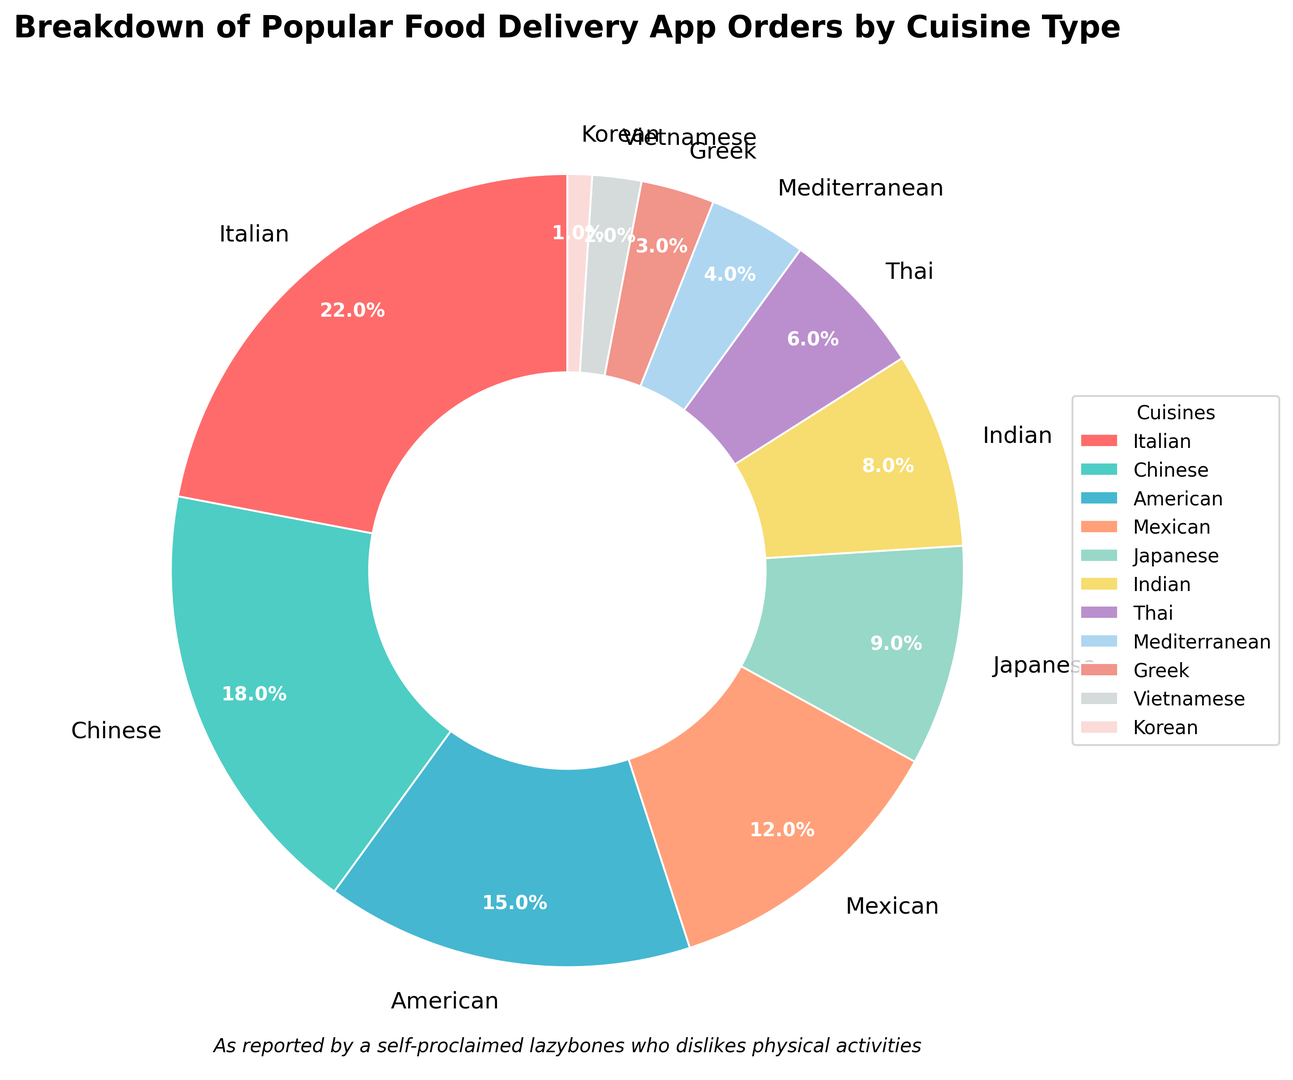Which cuisine has the highest percentage of orders? The cuisine with the highest percentage is labeled at 22% in the chart. By looking at the labels, Italian cuisine is marked at 22%.
Answer: Italian What is the combined percentage of American and Mexican orders? From the chart, American cuisine has 15% and Mexican cuisine has 12%. Adding these two percentages together gives 15% + 12% = 27%.
Answer: 27% Which cuisine has more orders, Japanese or Indian? By looking at the labels, Japanese cuisine has 9% and Indian cuisine has 8%. Since 9% is greater than 8%, Japanese cuisine has more orders.
Answer: Japanese How much more percentage does Chinese cuisine have compared to Thai cuisine? Chinese cuisine has 18% while Thai cuisine has 6%. The difference between these two percentages is 18% - 6% = 12%.
Answer: 12% Are there any cuisines that have the same percentage of orders? By looking at the pie chart, each label has a different percentage, so no two cuisines have the same percentage of orders.
Answer: No What percentage of orders comes from the least popular cuisine? The least popular cuisine is Korean, marked at 1% in the pie chart.
Answer: 1% What is the difference in percentage between the most popular and the second most popular cuisine? The most popular cuisine, Italian, has 22% and the second most popular, Chinese, has 18%. The difference is 22% - 18% = 4%.
Answer: 4% What is the total percentage for the bottom four cuisines? The bottom four cuisines are Mediterranean (4%), Greek (3%), Vietnamese (2%), and Korean (1%). Adding these together gives 4% + 3% + 2% + 1% = 10%.
Answer: 10% Which cuisine is represented by the orange color in the pie chart? Observing the colors in the chart, the orange segment corresponds to Mexican cuisine.
Answer: Mexican How many more percentage points does American cuisine have compared to Greek cuisine? American cuisine has 15% while Greek cuisine has 3%. The difference is 15% - 3% = 12%.
Answer: 12% 